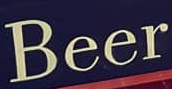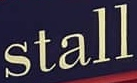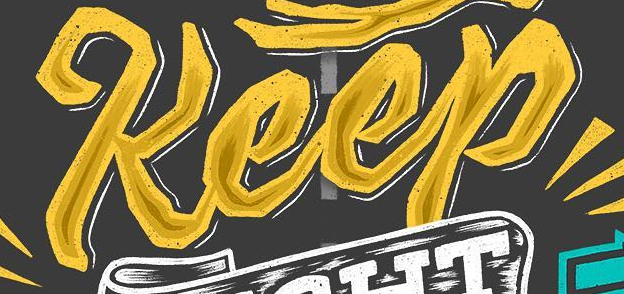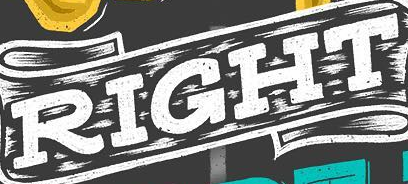Read the text from these images in sequence, separated by a semicolon. Beer; stall; Keep; RIGHT 